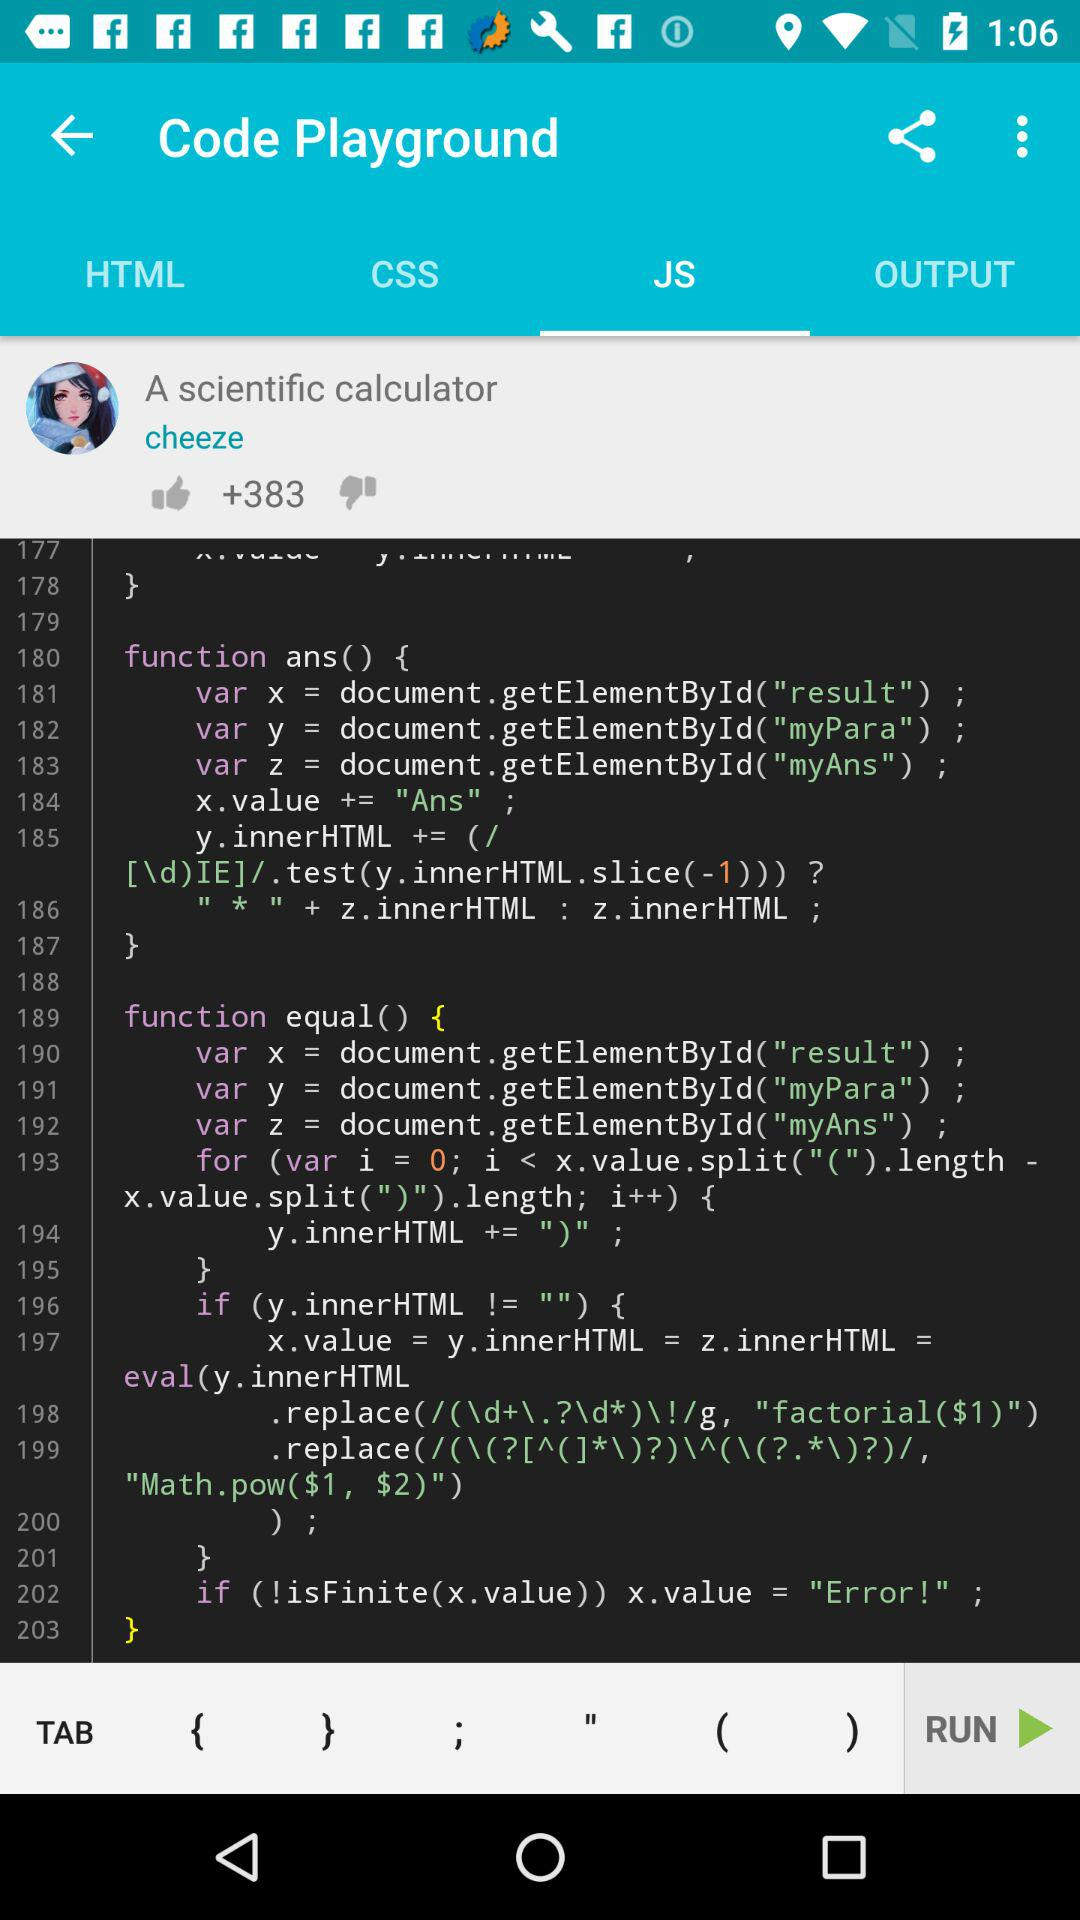What is the username? The username is "cheeze". 